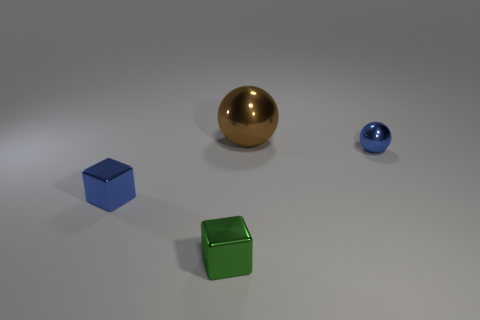Add 2 big brown things. How many objects exist? 6 Subtract all blue blocks. How many blocks are left? 1 Subtract all green blocks. Subtract all green spheres. How many blocks are left? 1 Subtract all gray cylinders. How many gray balls are left? 0 Subtract all tiny purple matte cubes. Subtract all blue cubes. How many objects are left? 3 Add 2 small shiny blocks. How many small shiny blocks are left? 4 Add 2 tiny green metallic objects. How many tiny green metallic objects exist? 3 Subtract 0 red cubes. How many objects are left? 4 Subtract 1 blocks. How many blocks are left? 1 